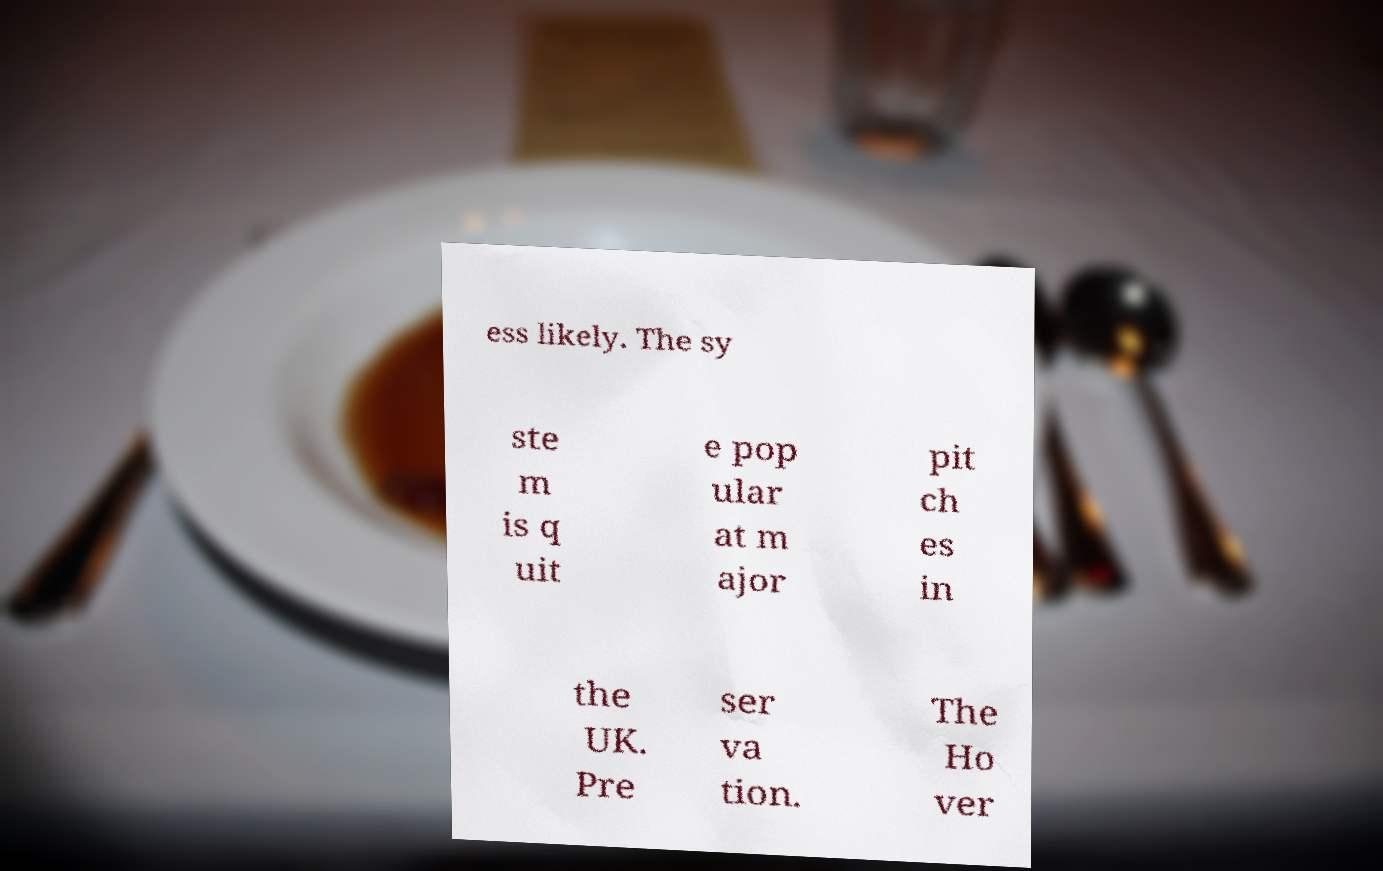Could you assist in decoding the text presented in this image and type it out clearly? ess likely. The sy ste m is q uit e pop ular at m ajor pit ch es in the UK. Pre ser va tion. The Ho ver 